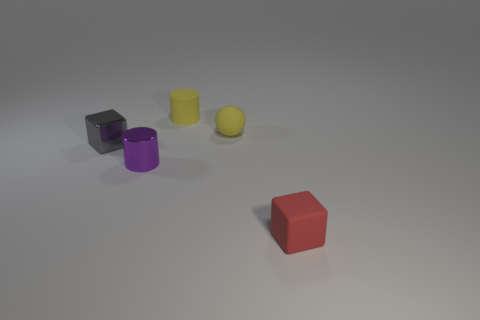What is the color of the block that is left of the matte object that is in front of the small purple metal object?
Ensure brevity in your answer.  Gray. How many big things are purple spheres or red things?
Provide a succinct answer. 0. How many tiny cylinders have the same material as the red object?
Provide a succinct answer. 1. What is the shape of the yellow object to the right of the cylinder that is on the right side of the purple object?
Your answer should be compact. Sphere. What number of gray metallic cubes are in front of the tiny block that is left of the matte thing in front of the gray block?
Ensure brevity in your answer.  0. Is the number of tiny yellow matte cylinders to the right of the small yellow matte cylinder less than the number of tiny green shiny cylinders?
Give a very brief answer. No. What is the shape of the small yellow thing that is in front of the tiny yellow matte cylinder?
Keep it short and to the point. Sphere. The small metal thing that is left of the metal object right of the small block that is to the left of the tiny purple metallic thing is what shape?
Ensure brevity in your answer.  Cube. How many objects are either gray objects or metal things?
Provide a short and direct response. 2. Is the shape of the small yellow matte object in front of the tiny yellow rubber cylinder the same as the thing behind the small ball?
Your answer should be compact. No. 